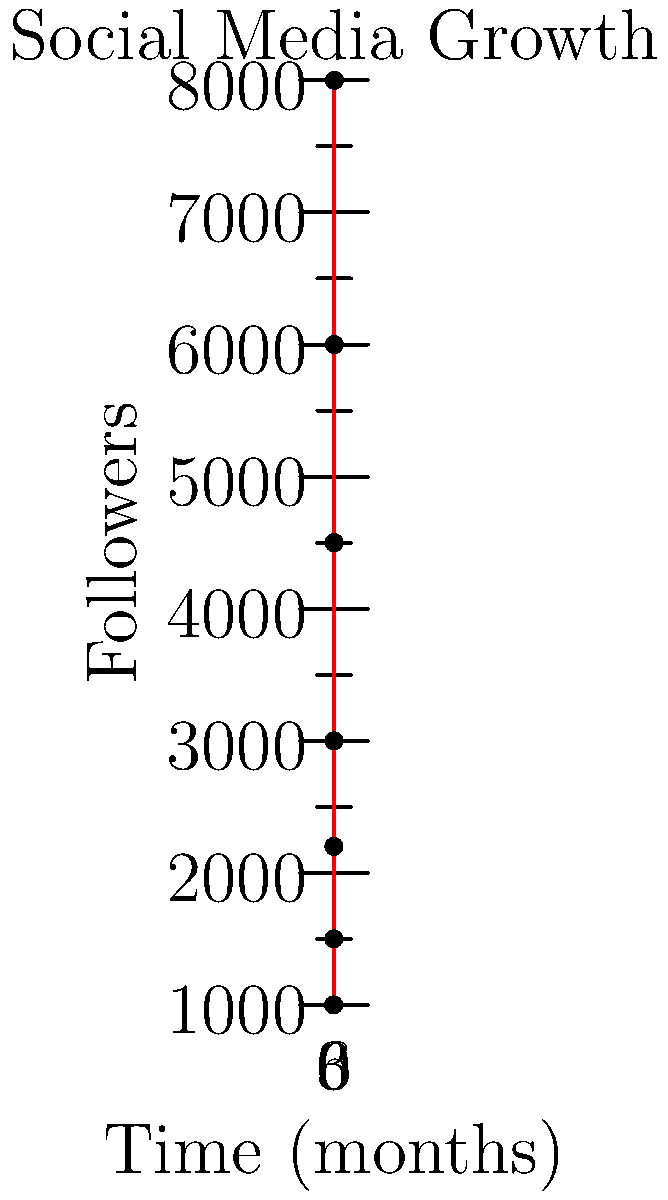As a freelance journalist tracking social media growth, you've plotted your follower count over the past 6 months. Based on the graph, what was the approximate increase in followers between the 2-month and 4-month marks? To solve this problem, we need to follow these steps:

1. Identify the follower count at the 2-month mark:
   At x = 2, y ≈ 2200 followers

2. Identify the follower count at the 4-month mark:
   At x = 4, y ≈ 4500 followers

3. Calculate the difference:
   $4500 - 2200 = 2300$

Therefore, the approximate increase in followers between the 2-month and 4-month marks is 2300.
Answer: 2300 followers 